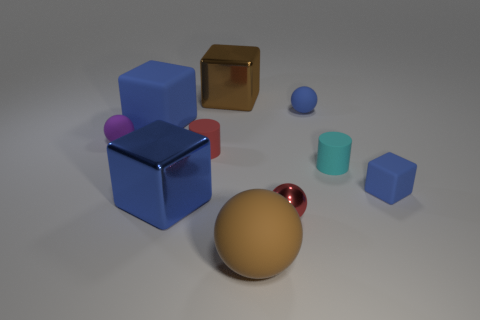How many blocks are either large blue matte things or large brown matte objects?
Keep it short and to the point. 1. How many blue objects are behind the red cylinder and on the left side of the brown cube?
Offer a terse response. 1. There is a big rubber thing behind the red shiny thing; what is its color?
Your response must be concise. Blue. What size is the blue sphere that is the same material as the brown sphere?
Provide a succinct answer. Small. There is a tiny matte cylinder that is to the left of the tiny metallic thing; how many large shiny cubes are on the left side of it?
Give a very brief answer. 1. What number of cylinders are to the right of the cyan cylinder?
Your answer should be compact. 0. There is a large metal block in front of the tiny thing to the left of the blue matte cube left of the large brown rubber thing; what color is it?
Offer a terse response. Blue. Do the rubber ball that is in front of the tiny metallic sphere and the matte block that is left of the large brown sphere have the same color?
Give a very brief answer. No. What shape is the brown object in front of the big blue block that is in front of the purple ball?
Provide a succinct answer. Sphere. Is there a purple ball of the same size as the cyan matte cylinder?
Offer a very short reply. Yes. 